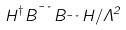Convert formula to latex. <formula><loc_0><loc_0><loc_500><loc_500>H ^ { \dagger } B ^ { \mu \nu } B _ { \mu \nu } H / \Lambda ^ { 2 }</formula> 